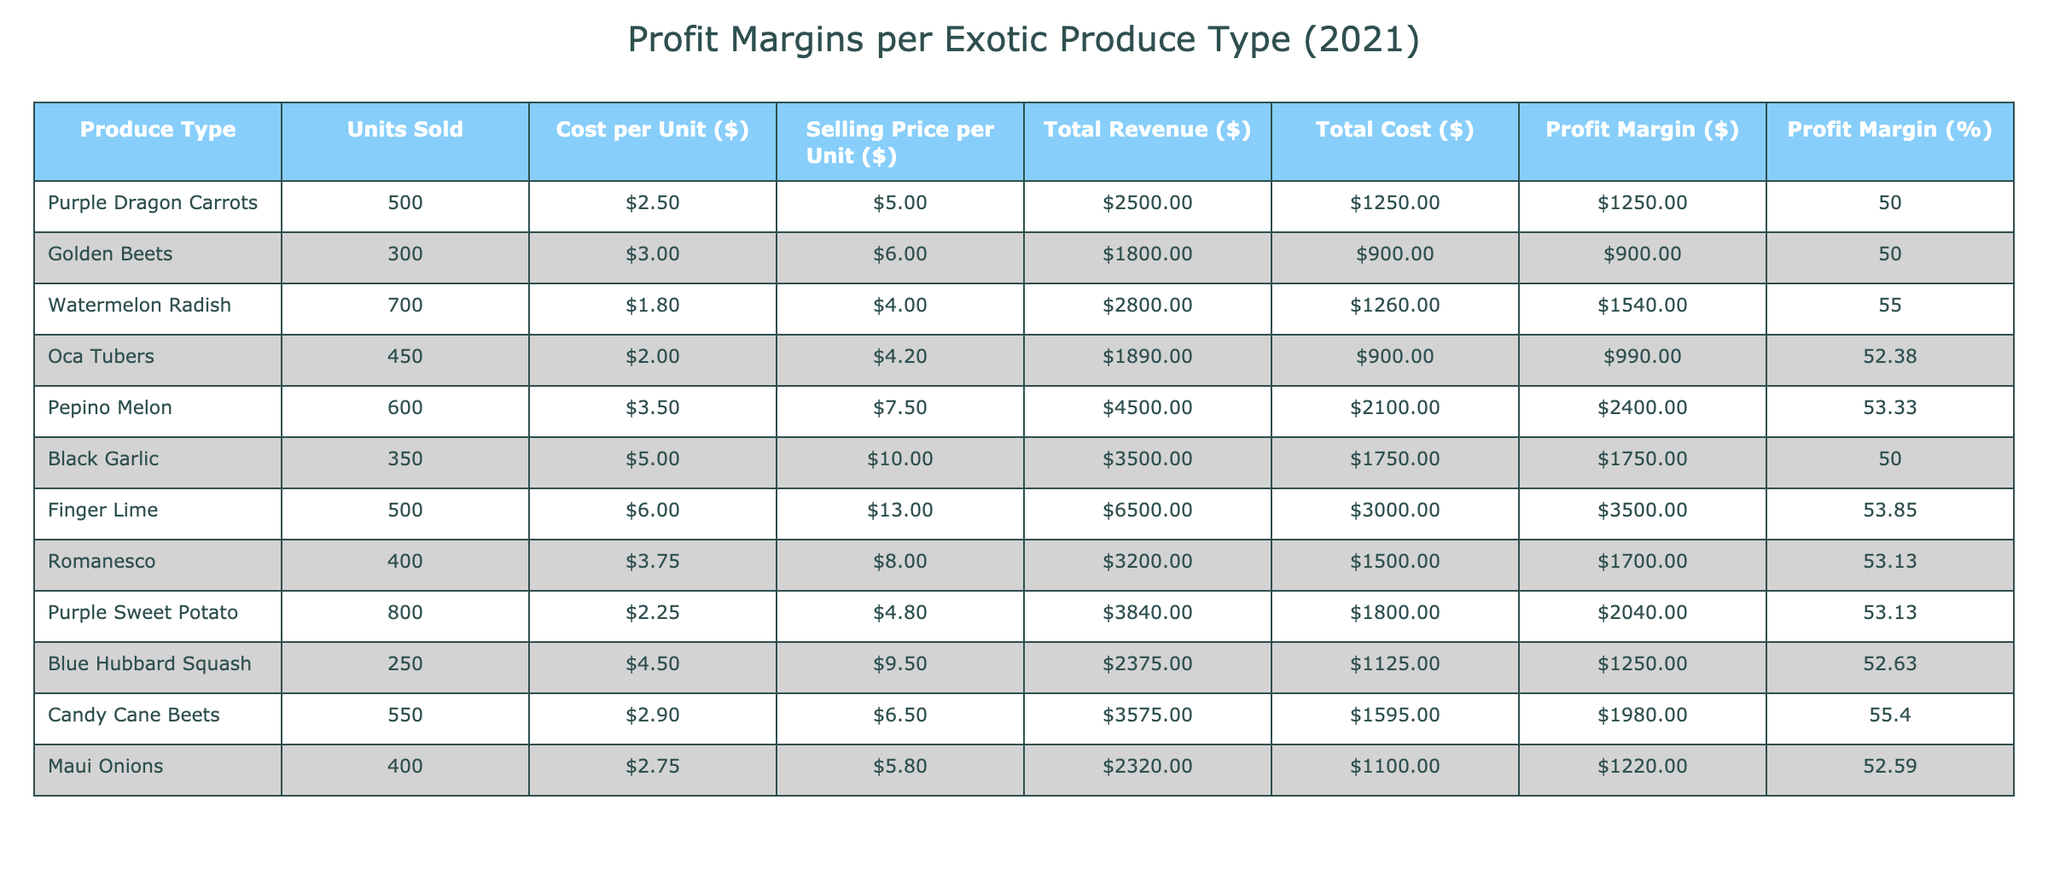What is the profit margin for Pepino Melon? The profit margin for Pepino Melon can be found in the table under the "Profit Margin (%)" column corresponding to that produce type, which shows 53.33%.
Answer: 53.33% How many units of Watermelon Radish were sold? The number of units sold for Watermelon Radish is listed in the "Units Sold" column. It shows 700 units.
Answer: 700 Which exotic produce has the highest total revenue? To determine the highest total revenue, we can compare the "Total Revenue ($)" values across all produce types. The highest value is 6500 for Finger Lime.
Answer: Finger Lime What is the total profit margin across all exotic produce types? To find the total profit margin, we sum the profit margins of each produce type and divide by the count of produce types. Calculating this gives us (1250 + 900 + 1540 + 990 + 2400 + 1750 + 3500 + 1700 + 2040 + 1250 + 1980 + 1220) = 15300 and there are 12 types, so the total profit margin percentage is 15300 / 36000 ≈ 42.50%.
Answer: 42.50% Is the profit margin for Golden Beets higher than 50%? The profit margin for Golden Beets is listed as 50%, which is not higher than 50%. Therefore, the answer is no.
Answer: No Which produce has the largest profit margin in dollar value? To find the largest profit margin in dollar value, we can look at the "Profit Margin ($)" column and find the maximum value, which is 3500 for Finger Lime.
Answer: Finger Lime What is the average selling price across all exotic produce types? To find the average selling price, we sum the "Selling Price per Unit ($)" values (5 + 6 + 4 + 4.20 + 7.50 + 10 + 13 + 8 + 4.80 + 9.50 + 6.50 + 5.80 = 81.20) and divide by 12, which gives us 81.20 / 12 ≈ 6.77.
Answer: 6.77 Did Candy Cane Beets have a profit margin percentage exceeding 55%? The profit margin percentage for Candy Cane Beets is shown as 55.40%, which is indeed greater than 55%. Therefore, the answer is yes.
Answer: Yes What is the difference in profit margin percentage between Purple Sweet Potato and Blue Hubbard Squash? The profit margin percentage for Purple Sweet Potato is 53.13% and for Blue Hubbard Squash, it is 52.63%. The difference is 53.13 - 52.63 = 0.50%.
Answer: 0.50% 